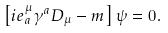<formula> <loc_0><loc_0><loc_500><loc_500>\left [ i e ^ { \mu } _ { a } \gamma ^ { a } D _ { \mu } - m \right ] \psi = 0 .</formula> 